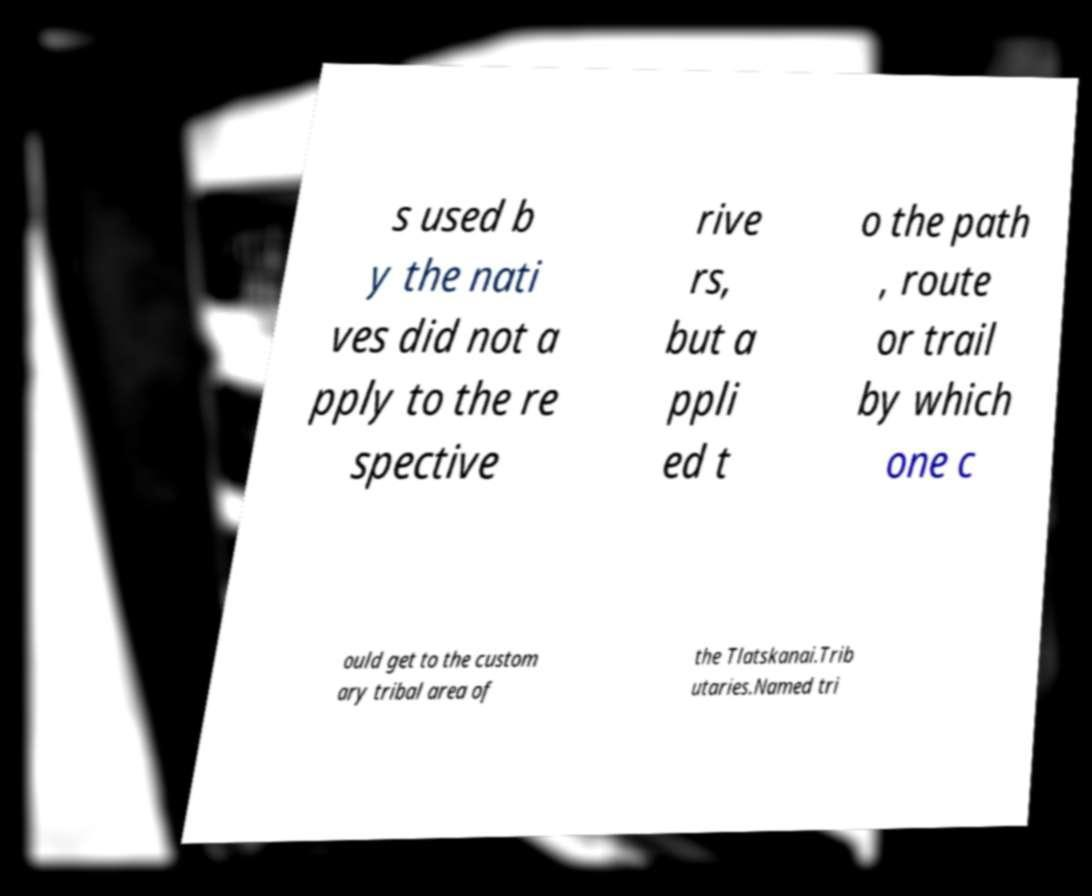Could you assist in decoding the text presented in this image and type it out clearly? s used b y the nati ves did not a pply to the re spective rive rs, but a ppli ed t o the path , route or trail by which one c ould get to the custom ary tribal area of the Tlatskanai.Trib utaries.Named tri 